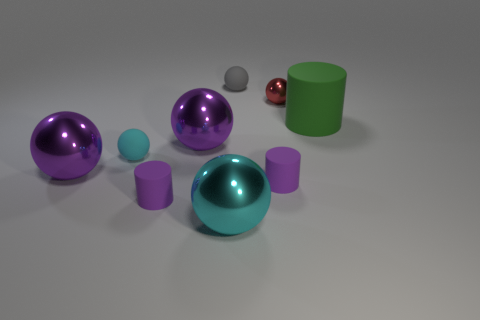Add 1 tiny cyan matte objects. How many objects exist? 10 Subtract all matte balls. How many balls are left? 4 Subtract all spheres. How many objects are left? 3 Subtract all purple cylinders. How many cylinders are left? 1 Add 2 big matte things. How many big matte things are left? 3 Add 6 big shiny spheres. How many big shiny spheres exist? 9 Subtract 0 gray cylinders. How many objects are left? 9 Subtract 5 balls. How many balls are left? 1 Subtract all yellow balls. Subtract all green cylinders. How many balls are left? 6 Subtract all green cylinders. How many purple spheres are left? 2 